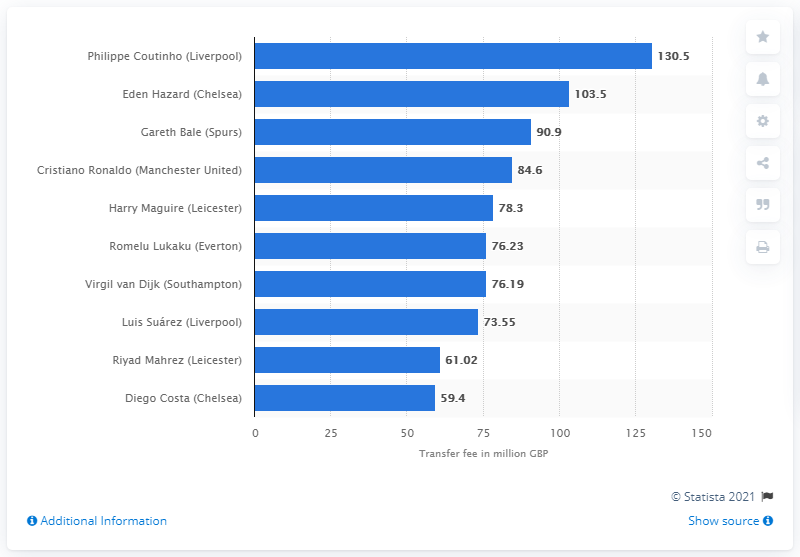List a handful of essential elements in this visual. Philippe Coutinho was transferred for a fee of 130.5 million dollars. 